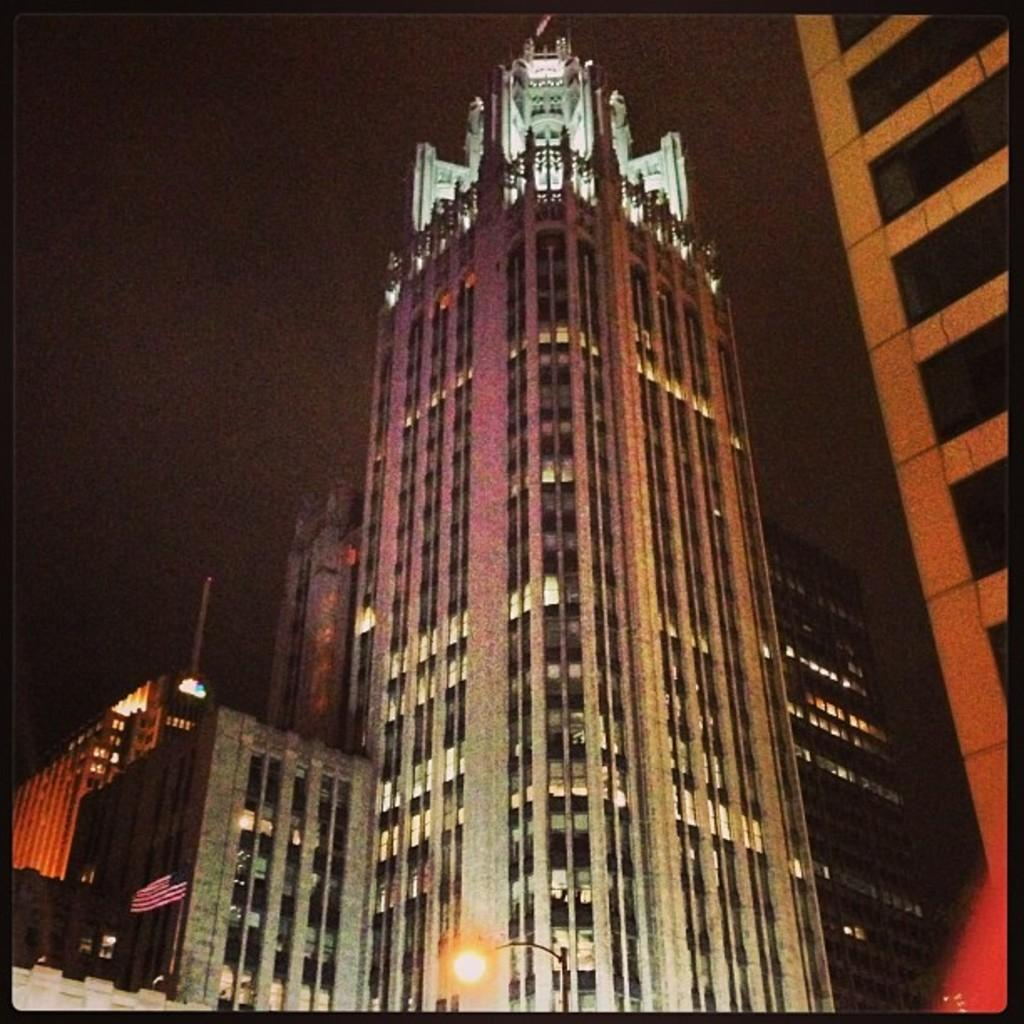What is the main subject in the center of the image? There are buildings in the center of the image. What can be seen at the bottom of the image? There is a street light at the bottom of the image. What type of crack can be seen on the buildings in the image? There is no crack visible on the buildings in the image. Can you see any children playing near the street light in the image? There is no indication of children playing or any people near the street light in the image. 